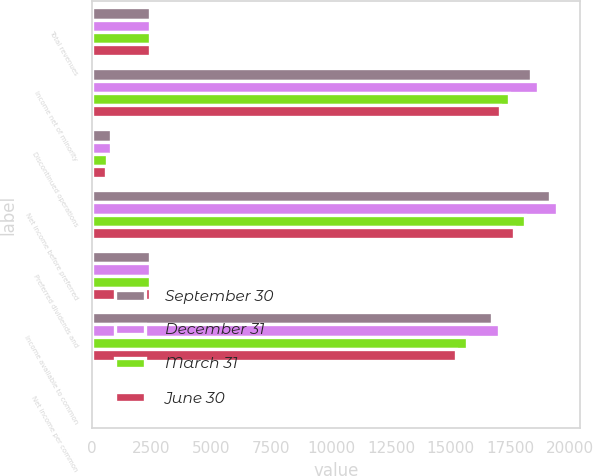<chart> <loc_0><loc_0><loc_500><loc_500><stacked_bar_chart><ecel><fcel>Total revenues<fcel>Income net of minority<fcel>Discontinued operations<fcel>Net income before preferred<fcel>Preferred dividends and<fcel>Income available to common<fcel>Net income per common<nl><fcel>September 30<fcel>2423<fcel>18363<fcel>803<fcel>19166<fcel>2423<fcel>16743<fcel>0.54<nl><fcel>December 31<fcel>2423<fcel>18647<fcel>789<fcel>19436<fcel>2423<fcel>17013<fcel>0.54<nl><fcel>March 31<fcel>2423<fcel>17448<fcel>650<fcel>18098<fcel>2423<fcel>15675<fcel>0.51<nl><fcel>June 30<fcel>2423<fcel>17043<fcel>593<fcel>17636<fcel>2423<fcel>15213<fcel>0.5<nl></chart> 